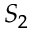<formula> <loc_0><loc_0><loc_500><loc_500>S _ { 2 }</formula> 